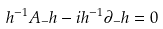Convert formula to latex. <formula><loc_0><loc_0><loc_500><loc_500>h ^ { - 1 } A _ { - } h - i h ^ { - 1 } \partial _ { - } h = 0</formula> 